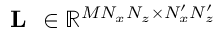Convert formula to latex. <formula><loc_0><loc_0><loc_500><loc_500>L \in \mathbb { R } ^ { M N _ { x } N _ { z } \times N _ { x } ^ { \prime } N _ { z } ^ { \prime } }</formula> 